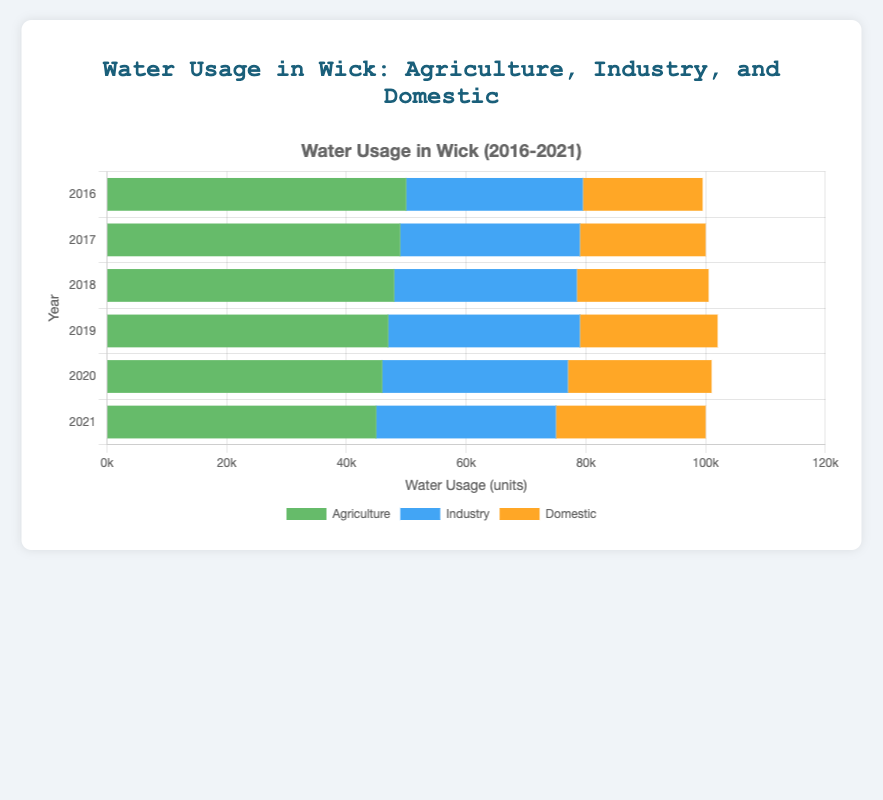What's the total water usage in 2021? To find the total water usage in 2021, add the water usage for Agriculture (45000), Industry (30000), and Domestic (25000). So, 45000 + 30000 + 25000 = 100000.
Answer: 100000 Which sector consistently uses the most water each year? By observing each horizontal bar's section for Agriculture, Industry, and Domestic from 2016 to 2021, the Agriculture section is consistently the longest. This indicates that Agriculture uses the most water each year.
Answer: Agriculture How did Domestic water usage change from 2016 to 2021? To determine the change, subtract the Domestic water usage in 2016 (20000) from the usage in 2021 (25000). So, 25000 - 20000 = 5000, indicating an increase of 5000 units.
Answer: Increased by 5000 What was the difference in Industry water usage between 2018 and 2019? To find the difference, subtract the Industry water usage in 2018 (30500) from that in 2019 (32000). So, 32000 - 30500 = 1500.
Answer: 1500 Which year had the lowest total water usage? To find the year with the lowest total water usage, visually compare the total lengths of the horizontal stacked bars for all years. 2021 has the shortest bar, indicating the lowest total usage.
Answer: 2021 By how much did Agriculture's water usage decrease from 2016 to 2021? Subtract Agriculture's water usage in 2021 (45000) from its usage in 2016 (50000). So, 50000 - 45000 = 5000.
Answer: 5000 Between which two consecutive years did the total water usage change the most? Calculate the total water usage for each year and then find the differences between consecutive years. The changes in total water usage are as follows: 2016-2017: -2000, 2017-2018: -500, 2018-2019: -3000, 2019-2020: -3000, 2020-2021: -1000. The biggest change is between 2019 and 2020 with a decrease of 3000.
Answer: 2019 and 2020 Which sector's water usage has remained the most stable over the years? Compare the variation in water usage for Agriculture, Industry, and Domestic from 2016 to 2021. The Industry sector shows the least fluctuation in values, indicating the most stability.
Answer: Industry 